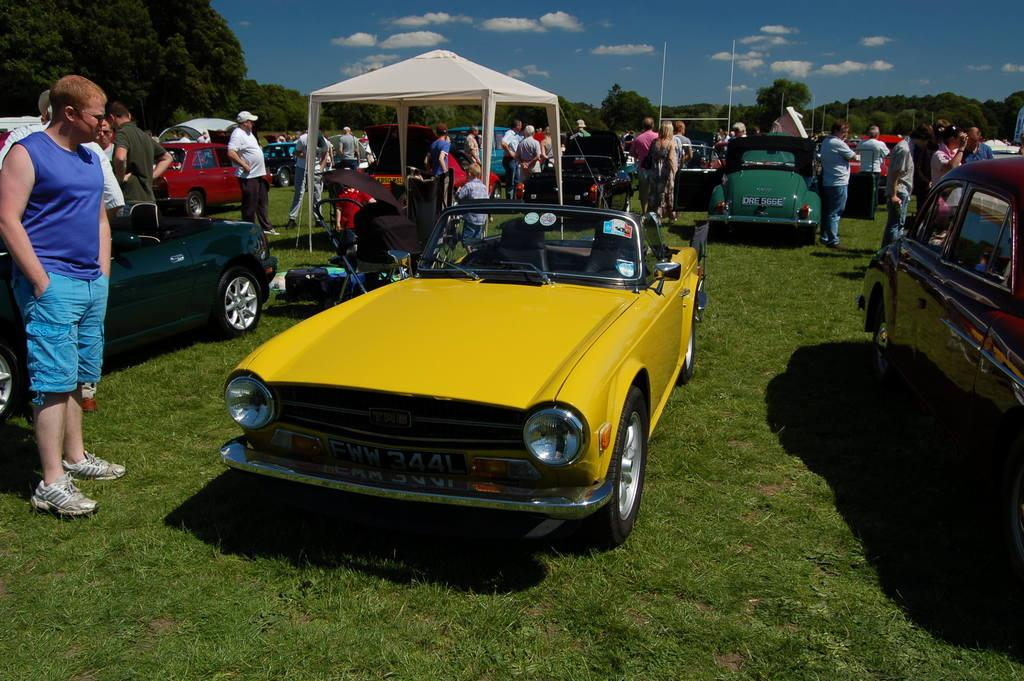What is the primary vegetation covering the land in the image? The land is covered with grass. How would you describe the sky in the image? The sky is cloudy. What types of objects can be seen in the image? There are vehicles and a baby chair present in the image. Are there any people visible in the image? Yes, there are people in the image. What type of shelter is present in the image? There is a tent in the image. What can be seen in the background of the image? Trees are visible in the background of the image. How many eyes can be seen on the pies in the image? There are no pies present in the image, so it is not possible to determine the number of eyes on them. 